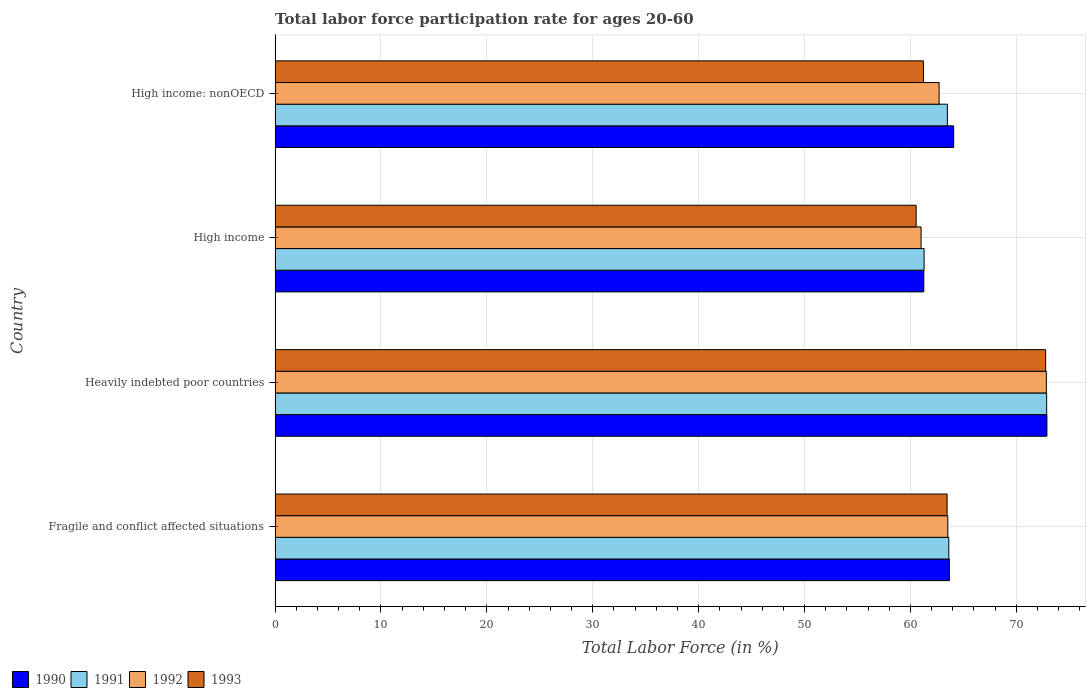Are the number of bars per tick equal to the number of legend labels?
Offer a terse response. Yes. What is the labor force participation rate in 1993 in Fragile and conflict affected situations?
Offer a very short reply. 63.46. Across all countries, what is the maximum labor force participation rate in 1993?
Ensure brevity in your answer.  72.77. Across all countries, what is the minimum labor force participation rate in 1991?
Keep it short and to the point. 61.29. In which country was the labor force participation rate in 1992 maximum?
Your answer should be compact. Heavily indebted poor countries. What is the total labor force participation rate in 1991 in the graph?
Make the answer very short. 261.26. What is the difference between the labor force participation rate in 1992 in Heavily indebted poor countries and that in High income: nonOECD?
Your response must be concise. 10.13. What is the difference between the labor force participation rate in 1993 in Fragile and conflict affected situations and the labor force participation rate in 1991 in High income: nonOECD?
Provide a short and direct response. -0.03. What is the average labor force participation rate in 1991 per country?
Make the answer very short. 65.32. What is the difference between the labor force participation rate in 1993 and labor force participation rate in 1991 in Fragile and conflict affected situations?
Make the answer very short. -0.16. What is the ratio of the labor force participation rate in 1992 in Heavily indebted poor countries to that in High income?
Offer a terse response. 1.19. Is the labor force participation rate in 1992 in Fragile and conflict affected situations less than that in High income?
Your answer should be compact. No. Is the difference between the labor force participation rate in 1993 in Fragile and conflict affected situations and High income greater than the difference between the labor force participation rate in 1991 in Fragile and conflict affected situations and High income?
Keep it short and to the point. Yes. What is the difference between the highest and the second highest labor force participation rate in 1991?
Keep it short and to the point. 9.24. What is the difference between the highest and the lowest labor force participation rate in 1993?
Make the answer very short. 12.23. Is the sum of the labor force participation rate in 1993 in Heavily indebted poor countries and High income greater than the maximum labor force participation rate in 1990 across all countries?
Your answer should be very brief. Yes. Is it the case that in every country, the sum of the labor force participation rate in 1991 and labor force participation rate in 1992 is greater than the sum of labor force participation rate in 1993 and labor force participation rate in 1990?
Your response must be concise. No. How many bars are there?
Keep it short and to the point. 16. Are the values on the major ticks of X-axis written in scientific E-notation?
Provide a succinct answer. No. Does the graph contain any zero values?
Give a very brief answer. No. What is the title of the graph?
Keep it short and to the point. Total labor force participation rate for ages 20-60. What is the Total Labor Force (in %) in 1990 in Fragile and conflict affected situations?
Your response must be concise. 63.68. What is the Total Labor Force (in %) in 1991 in Fragile and conflict affected situations?
Your answer should be very brief. 63.62. What is the Total Labor Force (in %) in 1992 in Fragile and conflict affected situations?
Make the answer very short. 63.53. What is the Total Labor Force (in %) of 1993 in Fragile and conflict affected situations?
Make the answer very short. 63.46. What is the Total Labor Force (in %) of 1990 in Heavily indebted poor countries?
Keep it short and to the point. 72.89. What is the Total Labor Force (in %) in 1991 in Heavily indebted poor countries?
Make the answer very short. 72.86. What is the Total Labor Force (in %) of 1992 in Heavily indebted poor countries?
Your answer should be compact. 72.83. What is the Total Labor Force (in %) of 1993 in Heavily indebted poor countries?
Offer a very short reply. 72.77. What is the Total Labor Force (in %) in 1990 in High income?
Your answer should be very brief. 61.26. What is the Total Labor Force (in %) of 1991 in High income?
Offer a terse response. 61.29. What is the Total Labor Force (in %) of 1992 in High income?
Keep it short and to the point. 61. What is the Total Labor Force (in %) of 1993 in High income?
Ensure brevity in your answer.  60.54. What is the Total Labor Force (in %) of 1990 in High income: nonOECD?
Keep it short and to the point. 64.08. What is the Total Labor Force (in %) of 1991 in High income: nonOECD?
Make the answer very short. 63.49. What is the Total Labor Force (in %) of 1992 in High income: nonOECD?
Offer a terse response. 62.71. What is the Total Labor Force (in %) in 1993 in High income: nonOECD?
Provide a short and direct response. 61.23. Across all countries, what is the maximum Total Labor Force (in %) in 1990?
Keep it short and to the point. 72.89. Across all countries, what is the maximum Total Labor Force (in %) in 1991?
Your response must be concise. 72.86. Across all countries, what is the maximum Total Labor Force (in %) in 1992?
Give a very brief answer. 72.83. Across all countries, what is the maximum Total Labor Force (in %) of 1993?
Your response must be concise. 72.77. Across all countries, what is the minimum Total Labor Force (in %) in 1990?
Your answer should be compact. 61.26. Across all countries, what is the minimum Total Labor Force (in %) of 1991?
Your response must be concise. 61.29. Across all countries, what is the minimum Total Labor Force (in %) of 1992?
Make the answer very short. 61. Across all countries, what is the minimum Total Labor Force (in %) of 1993?
Offer a very short reply. 60.54. What is the total Total Labor Force (in %) in 1990 in the graph?
Your answer should be compact. 261.91. What is the total Total Labor Force (in %) in 1991 in the graph?
Offer a very short reply. 261.26. What is the total Total Labor Force (in %) in 1992 in the graph?
Keep it short and to the point. 260.07. What is the total Total Labor Force (in %) of 1993 in the graph?
Provide a short and direct response. 258. What is the difference between the Total Labor Force (in %) in 1990 in Fragile and conflict affected situations and that in Heavily indebted poor countries?
Keep it short and to the point. -9.21. What is the difference between the Total Labor Force (in %) of 1991 in Fragile and conflict affected situations and that in Heavily indebted poor countries?
Offer a very short reply. -9.24. What is the difference between the Total Labor Force (in %) in 1992 in Fragile and conflict affected situations and that in Heavily indebted poor countries?
Your answer should be very brief. -9.31. What is the difference between the Total Labor Force (in %) of 1993 in Fragile and conflict affected situations and that in Heavily indebted poor countries?
Provide a succinct answer. -9.3. What is the difference between the Total Labor Force (in %) in 1990 in Fragile and conflict affected situations and that in High income?
Ensure brevity in your answer.  2.42. What is the difference between the Total Labor Force (in %) in 1991 in Fragile and conflict affected situations and that in High income?
Provide a short and direct response. 2.33. What is the difference between the Total Labor Force (in %) of 1992 in Fragile and conflict affected situations and that in High income?
Your response must be concise. 2.53. What is the difference between the Total Labor Force (in %) of 1993 in Fragile and conflict affected situations and that in High income?
Your answer should be compact. 2.92. What is the difference between the Total Labor Force (in %) in 1990 in Fragile and conflict affected situations and that in High income: nonOECD?
Your answer should be compact. -0.4. What is the difference between the Total Labor Force (in %) of 1991 in Fragile and conflict affected situations and that in High income: nonOECD?
Provide a short and direct response. 0.13. What is the difference between the Total Labor Force (in %) in 1992 in Fragile and conflict affected situations and that in High income: nonOECD?
Your answer should be compact. 0.82. What is the difference between the Total Labor Force (in %) in 1993 in Fragile and conflict affected situations and that in High income: nonOECD?
Give a very brief answer. 2.23. What is the difference between the Total Labor Force (in %) in 1990 in Heavily indebted poor countries and that in High income?
Keep it short and to the point. 11.62. What is the difference between the Total Labor Force (in %) in 1991 in Heavily indebted poor countries and that in High income?
Offer a terse response. 11.57. What is the difference between the Total Labor Force (in %) of 1992 in Heavily indebted poor countries and that in High income?
Your response must be concise. 11.83. What is the difference between the Total Labor Force (in %) in 1993 in Heavily indebted poor countries and that in High income?
Offer a terse response. 12.23. What is the difference between the Total Labor Force (in %) of 1990 in Heavily indebted poor countries and that in High income: nonOECD?
Make the answer very short. 8.8. What is the difference between the Total Labor Force (in %) in 1991 in Heavily indebted poor countries and that in High income: nonOECD?
Make the answer very short. 9.37. What is the difference between the Total Labor Force (in %) of 1992 in Heavily indebted poor countries and that in High income: nonOECD?
Provide a succinct answer. 10.13. What is the difference between the Total Labor Force (in %) in 1993 in Heavily indebted poor countries and that in High income: nonOECD?
Your response must be concise. 11.53. What is the difference between the Total Labor Force (in %) of 1990 in High income and that in High income: nonOECD?
Offer a terse response. -2.82. What is the difference between the Total Labor Force (in %) in 1991 in High income and that in High income: nonOECD?
Keep it short and to the point. -2.2. What is the difference between the Total Labor Force (in %) of 1992 in High income and that in High income: nonOECD?
Keep it short and to the point. -1.7. What is the difference between the Total Labor Force (in %) of 1993 in High income and that in High income: nonOECD?
Give a very brief answer. -0.7. What is the difference between the Total Labor Force (in %) in 1990 in Fragile and conflict affected situations and the Total Labor Force (in %) in 1991 in Heavily indebted poor countries?
Provide a succinct answer. -9.18. What is the difference between the Total Labor Force (in %) in 1990 in Fragile and conflict affected situations and the Total Labor Force (in %) in 1992 in Heavily indebted poor countries?
Your answer should be compact. -9.15. What is the difference between the Total Labor Force (in %) in 1990 in Fragile and conflict affected situations and the Total Labor Force (in %) in 1993 in Heavily indebted poor countries?
Make the answer very short. -9.09. What is the difference between the Total Labor Force (in %) in 1991 in Fragile and conflict affected situations and the Total Labor Force (in %) in 1992 in Heavily indebted poor countries?
Your answer should be very brief. -9.21. What is the difference between the Total Labor Force (in %) in 1991 in Fragile and conflict affected situations and the Total Labor Force (in %) in 1993 in Heavily indebted poor countries?
Your response must be concise. -9.15. What is the difference between the Total Labor Force (in %) in 1992 in Fragile and conflict affected situations and the Total Labor Force (in %) in 1993 in Heavily indebted poor countries?
Keep it short and to the point. -9.24. What is the difference between the Total Labor Force (in %) in 1990 in Fragile and conflict affected situations and the Total Labor Force (in %) in 1991 in High income?
Offer a very short reply. 2.39. What is the difference between the Total Labor Force (in %) in 1990 in Fragile and conflict affected situations and the Total Labor Force (in %) in 1992 in High income?
Your answer should be compact. 2.68. What is the difference between the Total Labor Force (in %) in 1990 in Fragile and conflict affected situations and the Total Labor Force (in %) in 1993 in High income?
Provide a succinct answer. 3.14. What is the difference between the Total Labor Force (in %) of 1991 in Fragile and conflict affected situations and the Total Labor Force (in %) of 1992 in High income?
Your answer should be very brief. 2.62. What is the difference between the Total Labor Force (in %) of 1991 in Fragile and conflict affected situations and the Total Labor Force (in %) of 1993 in High income?
Your response must be concise. 3.08. What is the difference between the Total Labor Force (in %) of 1992 in Fragile and conflict affected situations and the Total Labor Force (in %) of 1993 in High income?
Provide a succinct answer. 2.99. What is the difference between the Total Labor Force (in %) in 1990 in Fragile and conflict affected situations and the Total Labor Force (in %) in 1991 in High income: nonOECD?
Offer a very short reply. 0.19. What is the difference between the Total Labor Force (in %) of 1990 in Fragile and conflict affected situations and the Total Labor Force (in %) of 1992 in High income: nonOECD?
Provide a short and direct response. 0.97. What is the difference between the Total Labor Force (in %) of 1990 in Fragile and conflict affected situations and the Total Labor Force (in %) of 1993 in High income: nonOECD?
Give a very brief answer. 2.45. What is the difference between the Total Labor Force (in %) in 1991 in Fragile and conflict affected situations and the Total Labor Force (in %) in 1992 in High income: nonOECD?
Your answer should be compact. 0.91. What is the difference between the Total Labor Force (in %) of 1991 in Fragile and conflict affected situations and the Total Labor Force (in %) of 1993 in High income: nonOECD?
Your answer should be compact. 2.39. What is the difference between the Total Labor Force (in %) of 1992 in Fragile and conflict affected situations and the Total Labor Force (in %) of 1993 in High income: nonOECD?
Offer a very short reply. 2.3. What is the difference between the Total Labor Force (in %) in 1990 in Heavily indebted poor countries and the Total Labor Force (in %) in 1991 in High income?
Ensure brevity in your answer.  11.6. What is the difference between the Total Labor Force (in %) of 1990 in Heavily indebted poor countries and the Total Labor Force (in %) of 1992 in High income?
Offer a terse response. 11.88. What is the difference between the Total Labor Force (in %) of 1990 in Heavily indebted poor countries and the Total Labor Force (in %) of 1993 in High income?
Your response must be concise. 12.35. What is the difference between the Total Labor Force (in %) of 1991 in Heavily indebted poor countries and the Total Labor Force (in %) of 1992 in High income?
Keep it short and to the point. 11.86. What is the difference between the Total Labor Force (in %) of 1991 in Heavily indebted poor countries and the Total Labor Force (in %) of 1993 in High income?
Your response must be concise. 12.32. What is the difference between the Total Labor Force (in %) in 1992 in Heavily indebted poor countries and the Total Labor Force (in %) in 1993 in High income?
Offer a very short reply. 12.3. What is the difference between the Total Labor Force (in %) of 1990 in Heavily indebted poor countries and the Total Labor Force (in %) of 1991 in High income: nonOECD?
Give a very brief answer. 9.4. What is the difference between the Total Labor Force (in %) of 1990 in Heavily indebted poor countries and the Total Labor Force (in %) of 1992 in High income: nonOECD?
Make the answer very short. 10.18. What is the difference between the Total Labor Force (in %) in 1990 in Heavily indebted poor countries and the Total Labor Force (in %) in 1993 in High income: nonOECD?
Your response must be concise. 11.65. What is the difference between the Total Labor Force (in %) in 1991 in Heavily indebted poor countries and the Total Labor Force (in %) in 1992 in High income: nonOECD?
Keep it short and to the point. 10.15. What is the difference between the Total Labor Force (in %) of 1991 in Heavily indebted poor countries and the Total Labor Force (in %) of 1993 in High income: nonOECD?
Your answer should be compact. 11.63. What is the difference between the Total Labor Force (in %) in 1992 in Heavily indebted poor countries and the Total Labor Force (in %) in 1993 in High income: nonOECD?
Provide a succinct answer. 11.6. What is the difference between the Total Labor Force (in %) of 1990 in High income and the Total Labor Force (in %) of 1991 in High income: nonOECD?
Your response must be concise. -2.23. What is the difference between the Total Labor Force (in %) in 1990 in High income and the Total Labor Force (in %) in 1992 in High income: nonOECD?
Offer a terse response. -1.44. What is the difference between the Total Labor Force (in %) of 1990 in High income and the Total Labor Force (in %) of 1993 in High income: nonOECD?
Your answer should be compact. 0.03. What is the difference between the Total Labor Force (in %) in 1991 in High income and the Total Labor Force (in %) in 1992 in High income: nonOECD?
Offer a terse response. -1.42. What is the difference between the Total Labor Force (in %) of 1991 in High income and the Total Labor Force (in %) of 1993 in High income: nonOECD?
Ensure brevity in your answer.  0.06. What is the difference between the Total Labor Force (in %) in 1992 in High income and the Total Labor Force (in %) in 1993 in High income: nonOECD?
Provide a succinct answer. -0.23. What is the average Total Labor Force (in %) in 1990 per country?
Keep it short and to the point. 65.48. What is the average Total Labor Force (in %) of 1991 per country?
Your answer should be very brief. 65.31. What is the average Total Labor Force (in %) of 1992 per country?
Give a very brief answer. 65.02. What is the average Total Labor Force (in %) in 1993 per country?
Your answer should be compact. 64.5. What is the difference between the Total Labor Force (in %) in 1990 and Total Labor Force (in %) in 1991 in Fragile and conflict affected situations?
Your answer should be very brief. 0.06. What is the difference between the Total Labor Force (in %) in 1990 and Total Labor Force (in %) in 1992 in Fragile and conflict affected situations?
Provide a short and direct response. 0.15. What is the difference between the Total Labor Force (in %) of 1990 and Total Labor Force (in %) of 1993 in Fragile and conflict affected situations?
Offer a very short reply. 0.22. What is the difference between the Total Labor Force (in %) in 1991 and Total Labor Force (in %) in 1992 in Fragile and conflict affected situations?
Offer a very short reply. 0.09. What is the difference between the Total Labor Force (in %) of 1991 and Total Labor Force (in %) of 1993 in Fragile and conflict affected situations?
Make the answer very short. 0.16. What is the difference between the Total Labor Force (in %) of 1992 and Total Labor Force (in %) of 1993 in Fragile and conflict affected situations?
Make the answer very short. 0.07. What is the difference between the Total Labor Force (in %) in 1990 and Total Labor Force (in %) in 1991 in Heavily indebted poor countries?
Offer a very short reply. 0.02. What is the difference between the Total Labor Force (in %) in 1990 and Total Labor Force (in %) in 1992 in Heavily indebted poor countries?
Ensure brevity in your answer.  0.05. What is the difference between the Total Labor Force (in %) in 1990 and Total Labor Force (in %) in 1993 in Heavily indebted poor countries?
Make the answer very short. 0.12. What is the difference between the Total Labor Force (in %) in 1991 and Total Labor Force (in %) in 1992 in Heavily indebted poor countries?
Offer a very short reply. 0.03. What is the difference between the Total Labor Force (in %) in 1991 and Total Labor Force (in %) in 1993 in Heavily indebted poor countries?
Offer a very short reply. 0.09. What is the difference between the Total Labor Force (in %) of 1992 and Total Labor Force (in %) of 1993 in Heavily indebted poor countries?
Your answer should be compact. 0.07. What is the difference between the Total Labor Force (in %) of 1990 and Total Labor Force (in %) of 1991 in High income?
Keep it short and to the point. -0.03. What is the difference between the Total Labor Force (in %) in 1990 and Total Labor Force (in %) in 1992 in High income?
Provide a succinct answer. 0.26. What is the difference between the Total Labor Force (in %) in 1990 and Total Labor Force (in %) in 1993 in High income?
Offer a terse response. 0.73. What is the difference between the Total Labor Force (in %) in 1991 and Total Labor Force (in %) in 1992 in High income?
Provide a succinct answer. 0.29. What is the difference between the Total Labor Force (in %) of 1991 and Total Labor Force (in %) of 1993 in High income?
Ensure brevity in your answer.  0.75. What is the difference between the Total Labor Force (in %) in 1992 and Total Labor Force (in %) in 1993 in High income?
Ensure brevity in your answer.  0.47. What is the difference between the Total Labor Force (in %) of 1990 and Total Labor Force (in %) of 1991 in High income: nonOECD?
Your answer should be very brief. 0.59. What is the difference between the Total Labor Force (in %) of 1990 and Total Labor Force (in %) of 1992 in High income: nonOECD?
Provide a succinct answer. 1.38. What is the difference between the Total Labor Force (in %) in 1990 and Total Labor Force (in %) in 1993 in High income: nonOECD?
Offer a very short reply. 2.85. What is the difference between the Total Labor Force (in %) of 1991 and Total Labor Force (in %) of 1992 in High income: nonOECD?
Your answer should be compact. 0.78. What is the difference between the Total Labor Force (in %) in 1991 and Total Labor Force (in %) in 1993 in High income: nonOECD?
Offer a very short reply. 2.25. What is the difference between the Total Labor Force (in %) in 1992 and Total Labor Force (in %) in 1993 in High income: nonOECD?
Your response must be concise. 1.47. What is the ratio of the Total Labor Force (in %) of 1990 in Fragile and conflict affected situations to that in Heavily indebted poor countries?
Your answer should be very brief. 0.87. What is the ratio of the Total Labor Force (in %) of 1991 in Fragile and conflict affected situations to that in Heavily indebted poor countries?
Keep it short and to the point. 0.87. What is the ratio of the Total Labor Force (in %) of 1992 in Fragile and conflict affected situations to that in Heavily indebted poor countries?
Provide a short and direct response. 0.87. What is the ratio of the Total Labor Force (in %) of 1993 in Fragile and conflict affected situations to that in Heavily indebted poor countries?
Offer a very short reply. 0.87. What is the ratio of the Total Labor Force (in %) of 1990 in Fragile and conflict affected situations to that in High income?
Offer a very short reply. 1.04. What is the ratio of the Total Labor Force (in %) of 1991 in Fragile and conflict affected situations to that in High income?
Provide a succinct answer. 1.04. What is the ratio of the Total Labor Force (in %) of 1992 in Fragile and conflict affected situations to that in High income?
Make the answer very short. 1.04. What is the ratio of the Total Labor Force (in %) in 1993 in Fragile and conflict affected situations to that in High income?
Keep it short and to the point. 1.05. What is the ratio of the Total Labor Force (in %) in 1991 in Fragile and conflict affected situations to that in High income: nonOECD?
Offer a terse response. 1. What is the ratio of the Total Labor Force (in %) of 1992 in Fragile and conflict affected situations to that in High income: nonOECD?
Give a very brief answer. 1.01. What is the ratio of the Total Labor Force (in %) of 1993 in Fragile and conflict affected situations to that in High income: nonOECD?
Your answer should be very brief. 1.04. What is the ratio of the Total Labor Force (in %) of 1990 in Heavily indebted poor countries to that in High income?
Provide a short and direct response. 1.19. What is the ratio of the Total Labor Force (in %) of 1991 in Heavily indebted poor countries to that in High income?
Provide a succinct answer. 1.19. What is the ratio of the Total Labor Force (in %) of 1992 in Heavily indebted poor countries to that in High income?
Your answer should be compact. 1.19. What is the ratio of the Total Labor Force (in %) in 1993 in Heavily indebted poor countries to that in High income?
Give a very brief answer. 1.2. What is the ratio of the Total Labor Force (in %) in 1990 in Heavily indebted poor countries to that in High income: nonOECD?
Your answer should be very brief. 1.14. What is the ratio of the Total Labor Force (in %) of 1991 in Heavily indebted poor countries to that in High income: nonOECD?
Give a very brief answer. 1.15. What is the ratio of the Total Labor Force (in %) in 1992 in Heavily indebted poor countries to that in High income: nonOECD?
Provide a succinct answer. 1.16. What is the ratio of the Total Labor Force (in %) in 1993 in Heavily indebted poor countries to that in High income: nonOECD?
Give a very brief answer. 1.19. What is the ratio of the Total Labor Force (in %) in 1990 in High income to that in High income: nonOECD?
Give a very brief answer. 0.96. What is the ratio of the Total Labor Force (in %) of 1991 in High income to that in High income: nonOECD?
Offer a very short reply. 0.97. What is the ratio of the Total Labor Force (in %) of 1992 in High income to that in High income: nonOECD?
Keep it short and to the point. 0.97. What is the ratio of the Total Labor Force (in %) in 1993 in High income to that in High income: nonOECD?
Provide a succinct answer. 0.99. What is the difference between the highest and the second highest Total Labor Force (in %) of 1990?
Your response must be concise. 8.8. What is the difference between the highest and the second highest Total Labor Force (in %) of 1991?
Ensure brevity in your answer.  9.24. What is the difference between the highest and the second highest Total Labor Force (in %) of 1992?
Provide a short and direct response. 9.31. What is the difference between the highest and the second highest Total Labor Force (in %) in 1993?
Your response must be concise. 9.3. What is the difference between the highest and the lowest Total Labor Force (in %) of 1990?
Your response must be concise. 11.62. What is the difference between the highest and the lowest Total Labor Force (in %) of 1991?
Your response must be concise. 11.57. What is the difference between the highest and the lowest Total Labor Force (in %) of 1992?
Your answer should be very brief. 11.83. What is the difference between the highest and the lowest Total Labor Force (in %) in 1993?
Give a very brief answer. 12.23. 